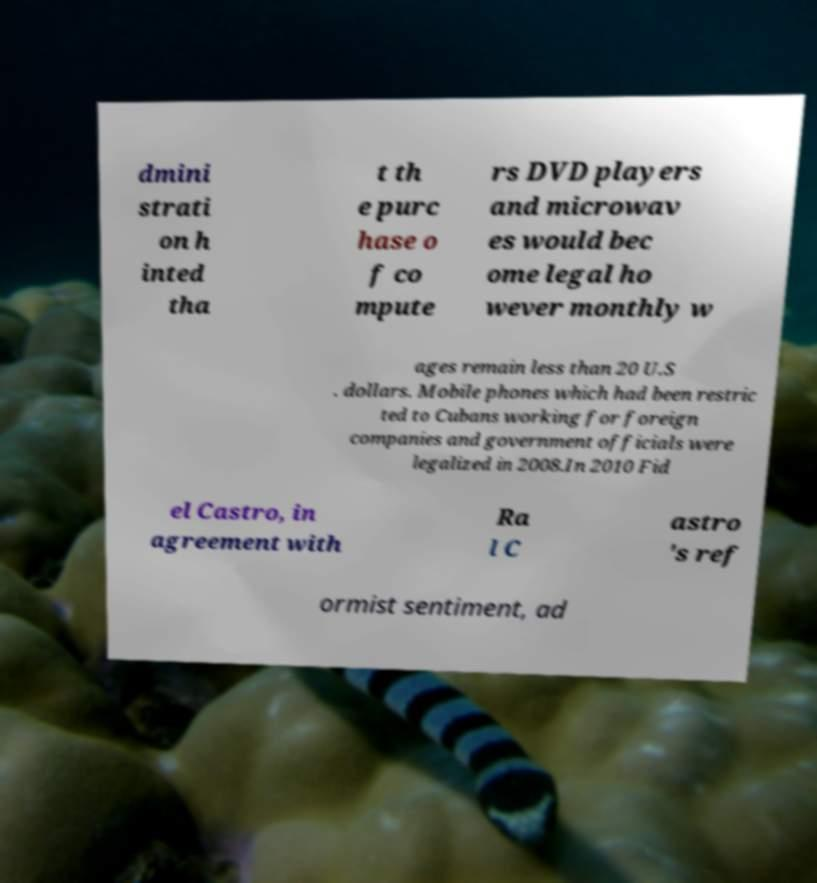Please identify and transcribe the text found in this image. dmini strati on h inted tha t th e purc hase o f co mpute rs DVD players and microwav es would bec ome legal ho wever monthly w ages remain less than 20 U.S . dollars. Mobile phones which had been restric ted to Cubans working for foreign companies and government officials were legalized in 2008.In 2010 Fid el Castro, in agreement with Ra l C astro 's ref ormist sentiment, ad 